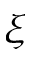Convert formula to latex. <formula><loc_0><loc_0><loc_500><loc_500>\xi</formula> 